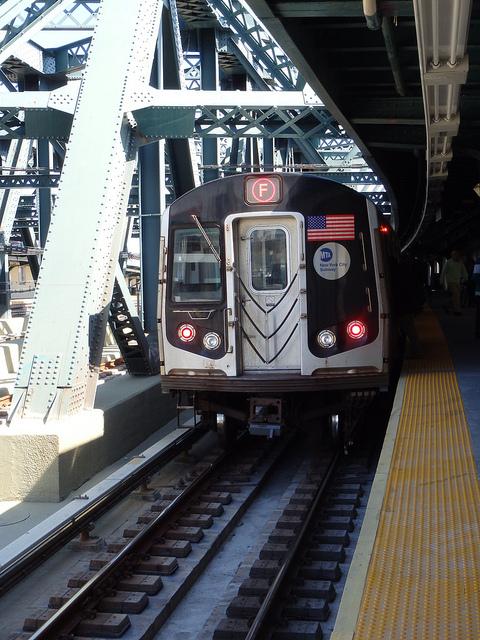What country does the flag by the door on the train represent?
Short answer required. Usa. What train is this?
Keep it brief. F. Are the train's lights visible?
Write a very short answer. Yes. 